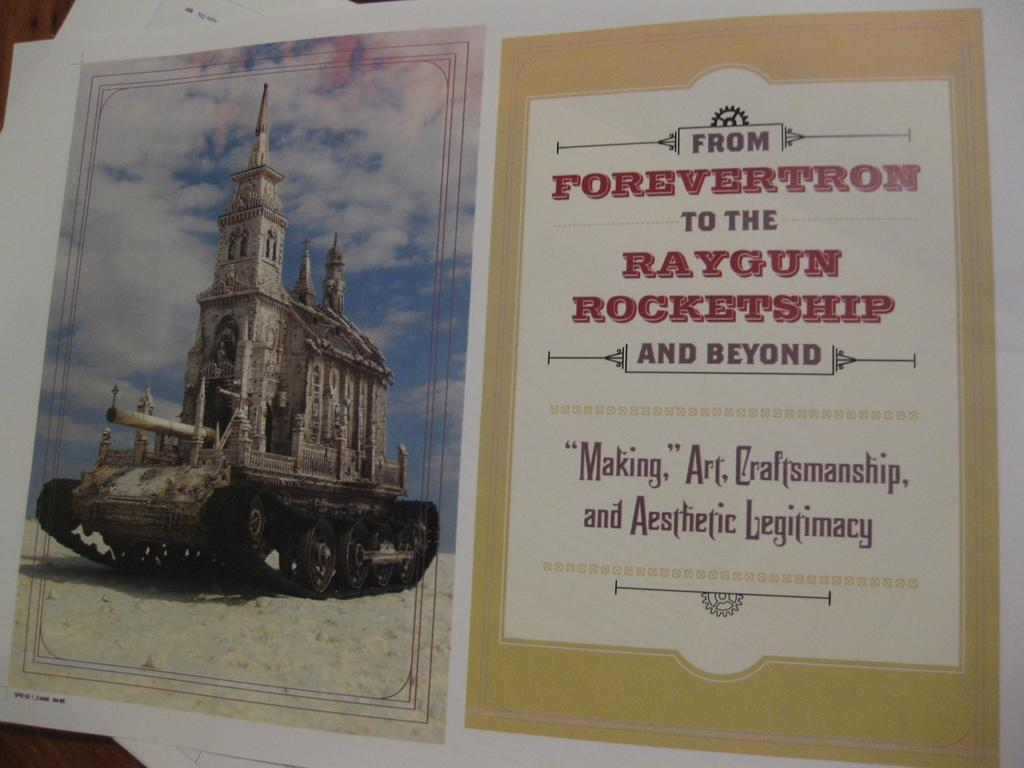<image>
Provide a brief description of the given image. A picture of a castle type building is accompanied by a message from Forevertron. 